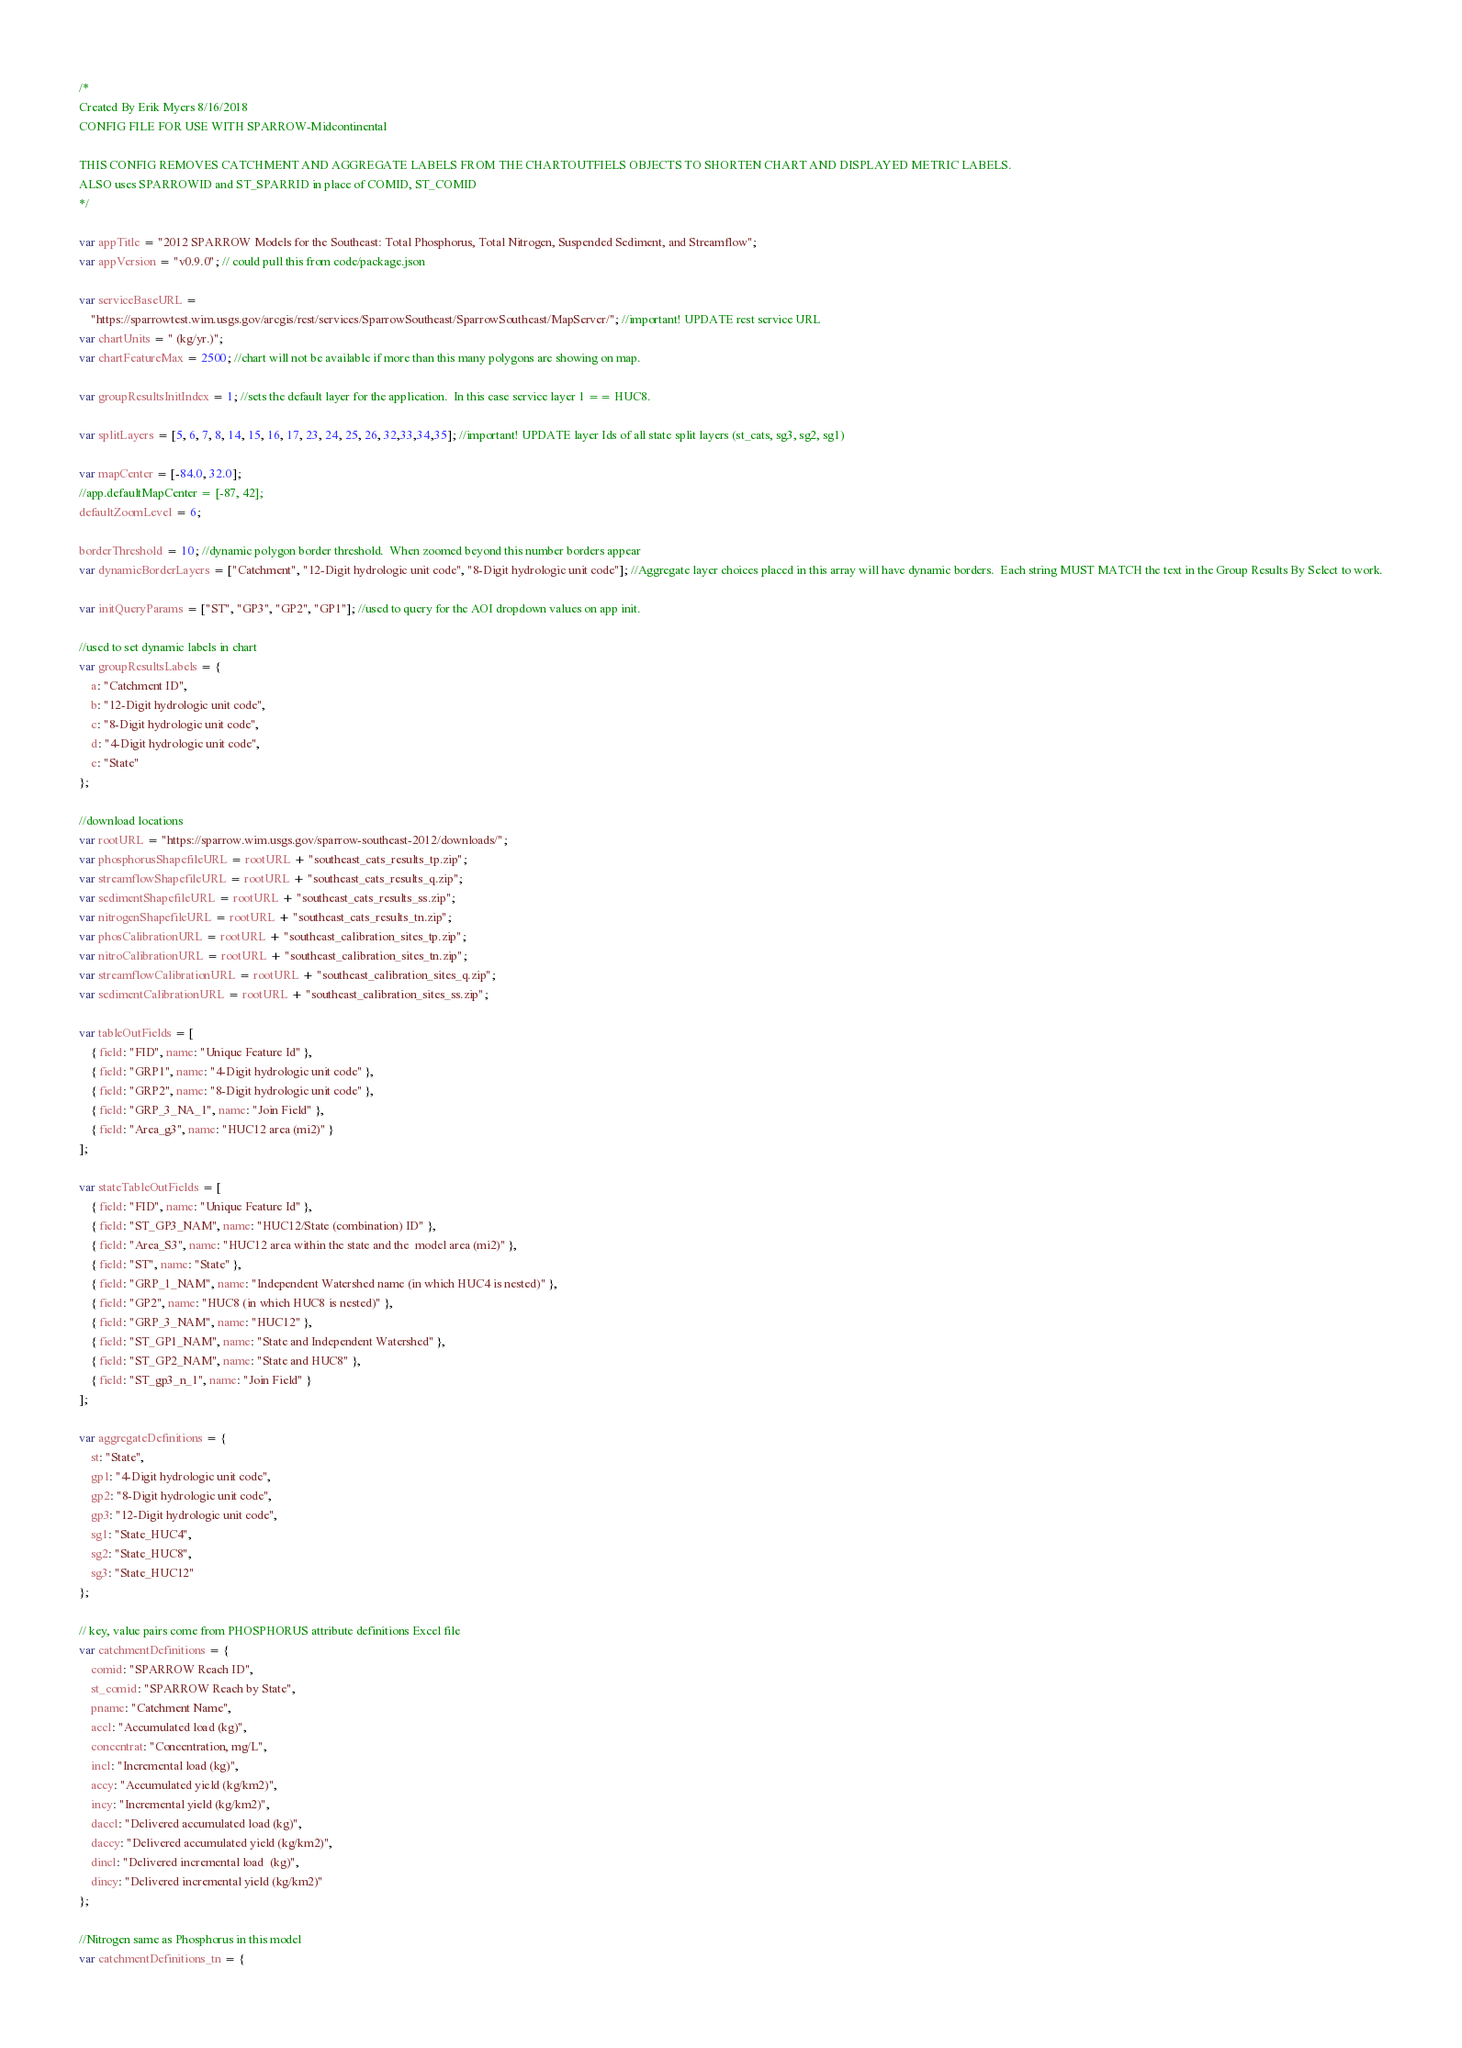Convert code to text. <code><loc_0><loc_0><loc_500><loc_500><_JavaScript_>/*
Created By Erik Myers 8/16/2018
CONFIG FILE FOR USE WITH SPARROW-Midcontinental

THIS CONFIG REMOVES CATCHMENT AND AGGREGATE LABELS FROM THE CHARTOUTFIELS OBJECTS TO SHORTEN CHART AND DISPLAYED METRIC LABELS.
ALSO uses SPARROWID and ST_SPARRID in place of COMID, ST_COMID
*/

var appTitle = "2012 SPARROW Models for the Southeast: Total Phosphorus, Total Nitrogen, Suspended Sediment, and Streamflow";
var appVersion = "v0.9.0"; // could pull this from code/package.json

var serviceBaseURL =
    "https://sparrowtest.wim.usgs.gov/arcgis/rest/services/SparrowSoutheast/SparrowSoutheast/MapServer/"; //important! UPDATE rest service URL
var chartUnits = " (kg/yr.)";
var chartFeatureMax = 2500; //chart will not be available if more than this many polygons are showing on map.

var groupResultsInitIndex = 1; //sets the default layer for the application.  In this case service layer 1 == HUC8.

var splitLayers = [5, 6, 7, 8, 14, 15, 16, 17, 23, 24, 25, 26, 32,33,34,35]; //important! UPDATE layer Ids of all state split layers (st_cats, sg3, sg2, sg1)

var mapCenter = [-84.0, 32.0];
//app.defaultMapCenter = [-87, 42];
defaultZoomLevel = 6;

borderThreshold = 10; //dynamic polygon border threshold.  When zoomed beyond this number borders appear
var dynamicBorderLayers = ["Catchment", "12-Digit hydrologic unit code", "8-Digit hydrologic unit code"]; //Aggregate layer choices placed in this array will have dynamic borders.  Each string MUST MATCH the text in the Group Results By Select to work.

var initQueryParams = ["ST", "GP3", "GP2", "GP1"]; //used to query for the AOI dropdown values on app init.

//used to set dynamic labels in chart
var groupResultsLabels = {
    a: "Catchment ID",
    b: "12-Digit hydrologic unit code",
    c: "8-Digit hydrologic unit code",
    d: "4-Digit hydrologic unit code",
    e: "State"
};

//download locations
var rootURL = "https://sparrow.wim.usgs.gov/sparrow-southeast-2012/downloads/";
var phosphorusShapefileURL = rootURL + "southeast_cats_results_tp.zip";
var streamflowShapefileURL = rootURL + "southeast_cats_results_q.zip";
var sedimentShapefileURL = rootURL + "southeast_cats_results_ss.zip";
var nitrogenShapefileURL = rootURL + "southeast_cats_results_tn.zip";
var phosCalibrationURL = rootURL + "southeast_calibration_sites_tp.zip";
var nitroCalibrationURL = rootURL + "southeast_calibration_sites_tn.zip";
var streamflowCalibrationURL = rootURL + "southeast_calibration_sites_q.zip";
var sedimentCalibrationURL = rootURL + "southeast_calibration_sites_ss.zip";

var tableOutFields = [
    { field: "FID", name: "Unique Feature Id" },
    { field: "GRP1", name: "4-Digit hydrologic unit code" },
    { field: "GRP2", name: "8-Digit hydrologic unit code" },
    { field: "GRP_3_NA_1", name: "Join Field" },
    { field: "Area_g3", name: "HUC12 area (mi2)" }
];

var stateTableOutFields = [
    { field: "FID", name: "Unique Feature Id" },
    { field: "ST_GP3_NAM", name: "HUC12/State (combination) ID" },
    { field: "Area_S3", name: "HUC12 area within the state and the  model area (mi2)" },
    { field: "ST", name: "State" },
    { field: "GRP_1_NAM", name: "Independent Watershed name (in which HUC4 is nested)" },
    { field: "GP2", name: "HUC8 (in which HUC8 is nested)" },
    { field: "GRP_3_NAM", name: "HUC12" },
    { field: "ST_GP1_NAM", name: "State and Independent Watershed" },
    { field: "ST_GP2_NAM", name: "State and HUC8" },
    { field: "ST_gp3_n_1", name: "Join Field" }
];

var aggregateDefinitions = {
    st: "State",
    gp1: "4-Digit hydrologic unit code",
    gp2: "8-Digit hydrologic unit code",
    gp3: "12-Digit hydrologic unit code",
    sg1: "State_HUC4",
    sg2: "State_HUC8",
    sg3: "State_HUC12"
};

// key, value pairs come from PHOSPHORUS attribute definitions Excel file
var catchmentDefinitions = {
    comid: "SPARROW Reach ID",
    st_comid: "SPARROW Reach by State",
    pname: "Catchment Name",
    accl: "Accumulated load (kg)",
    concentrat: "Concentration, mg/L",
    incl: "Incremental load (kg)",
    accy: "Accumulated yield (kg/km2)",
    incy: "Incremental yield (kg/km2)",
    daccl: "Delivered accumulated load (kg)",
    daccy: "Delivered accumulated yield (kg/km2)",
    dincl: "Delivered incremental load  (kg)",
    dincy: "Delivered incremental yield (kg/km2)"
};

//Nitrogen same as Phosphorus in this model
var catchmentDefinitions_tn = {</code> 